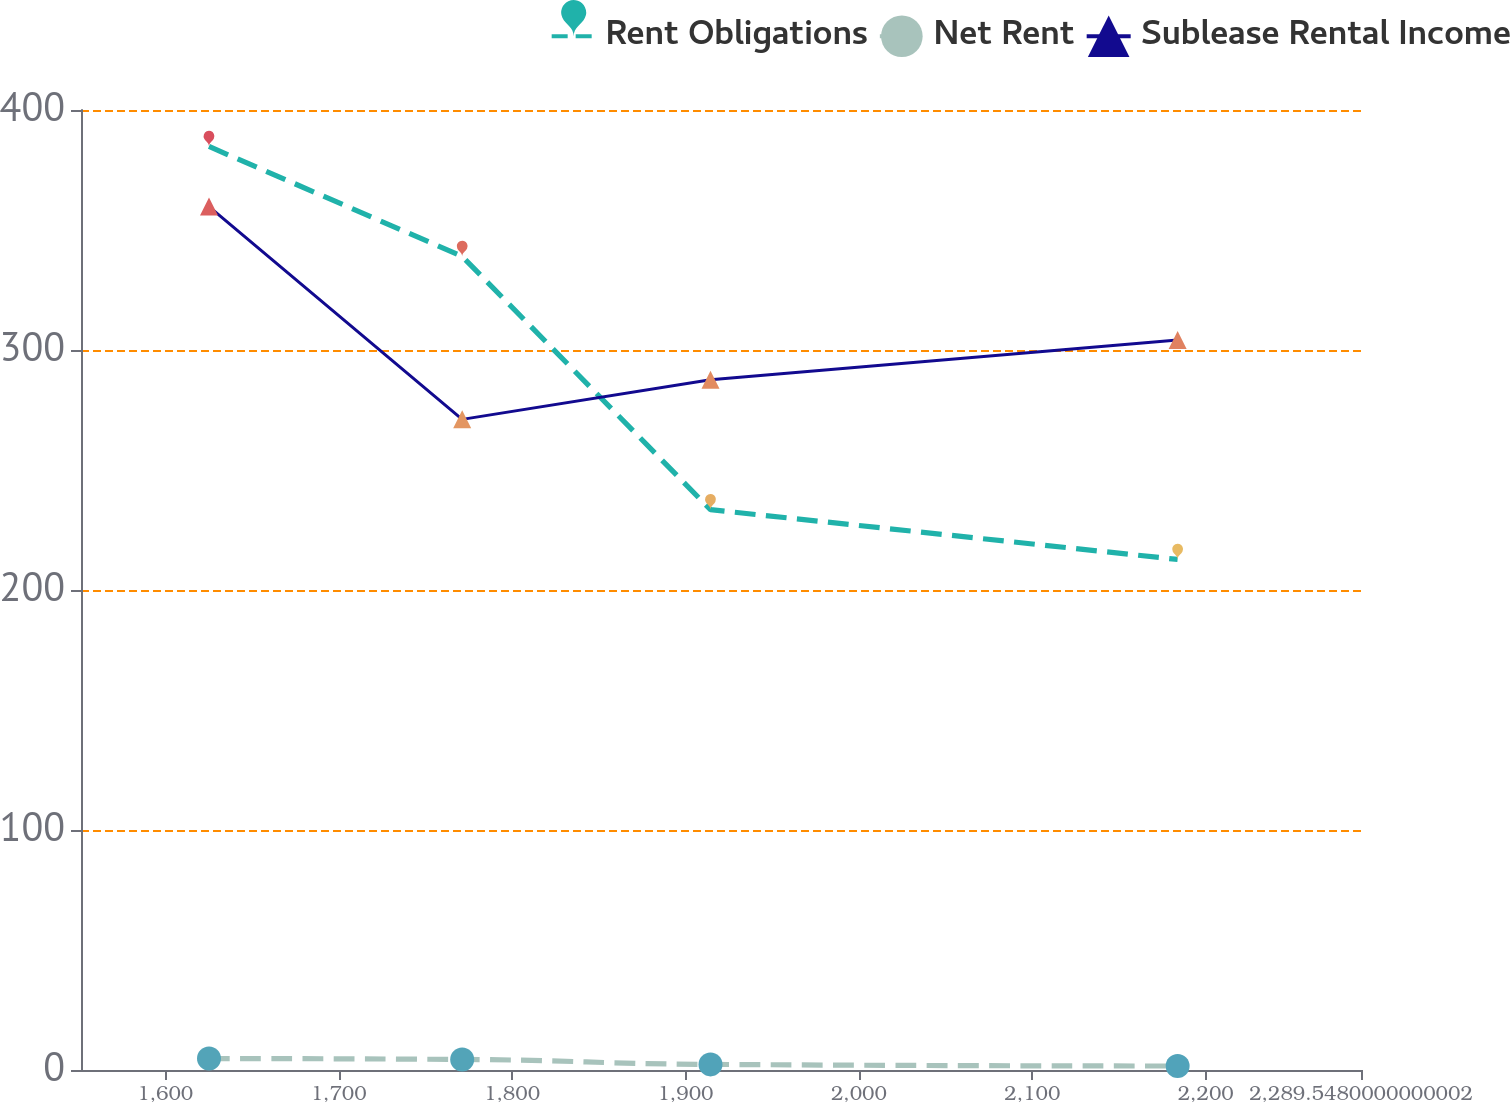Convert chart. <chart><loc_0><loc_0><loc_500><loc_500><line_chart><ecel><fcel>Rent Obligations<fcel>Net Rent<fcel>Sublease Rental Income<nl><fcel>1625.24<fcel>384.8<fcel>4.77<fcel>359.74<nl><fcel>1771.24<fcel>339<fcel>4.39<fcel>271.1<nl><fcel>1914.43<fcel>233.47<fcel>2.34<fcel>287.61<nl><fcel>2183.8<fcel>212.73<fcel>1.66<fcel>304.12<nl><fcel>2363.36<fcel>193.61<fcel>0.75<fcel>194.68<nl></chart> 